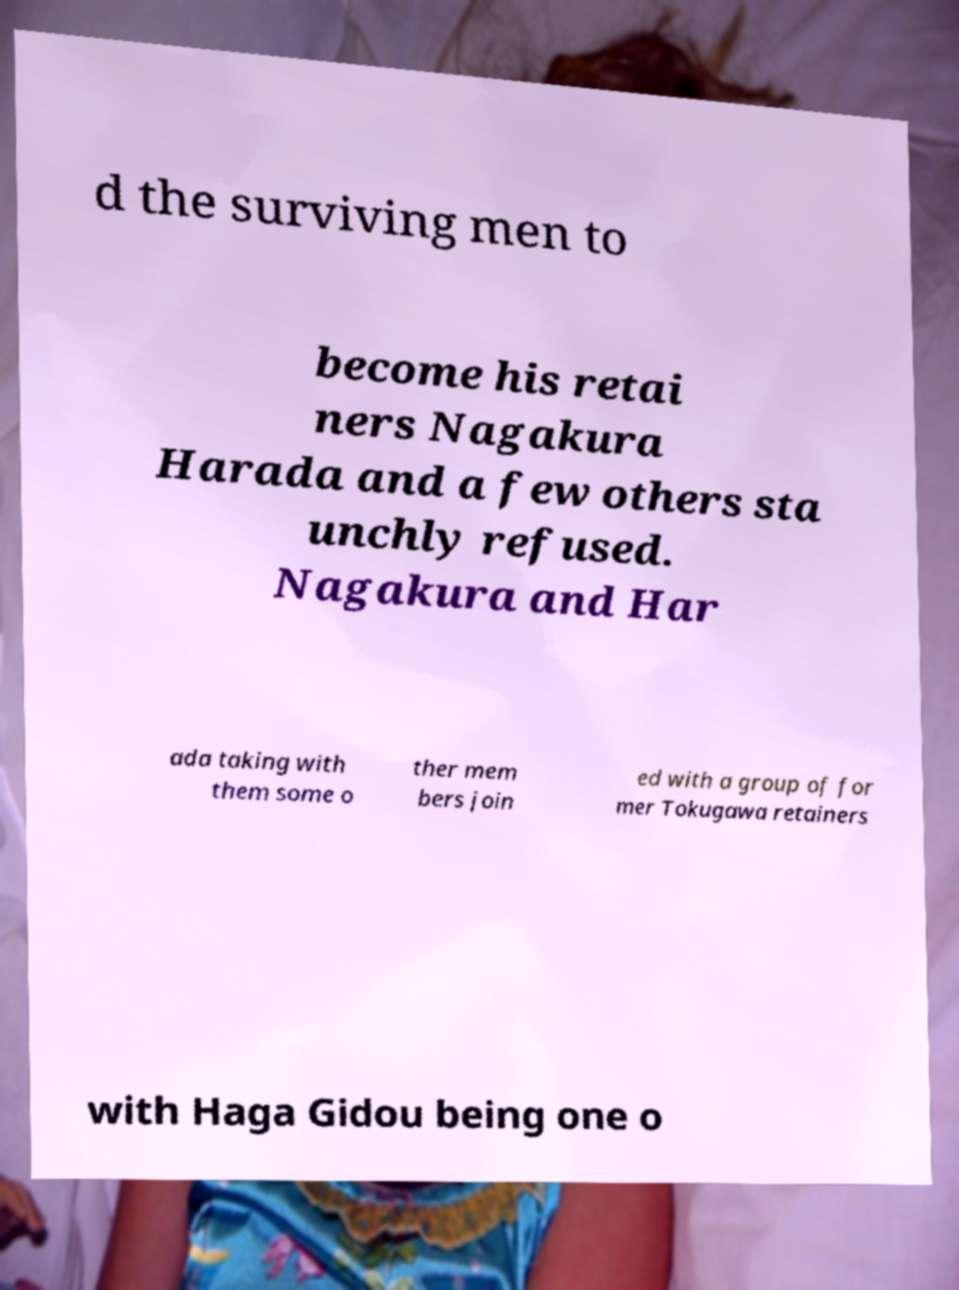Please identify and transcribe the text found in this image. d the surviving men to become his retai ners Nagakura Harada and a few others sta unchly refused. Nagakura and Har ada taking with them some o ther mem bers join ed with a group of for mer Tokugawa retainers with Haga Gidou being one o 